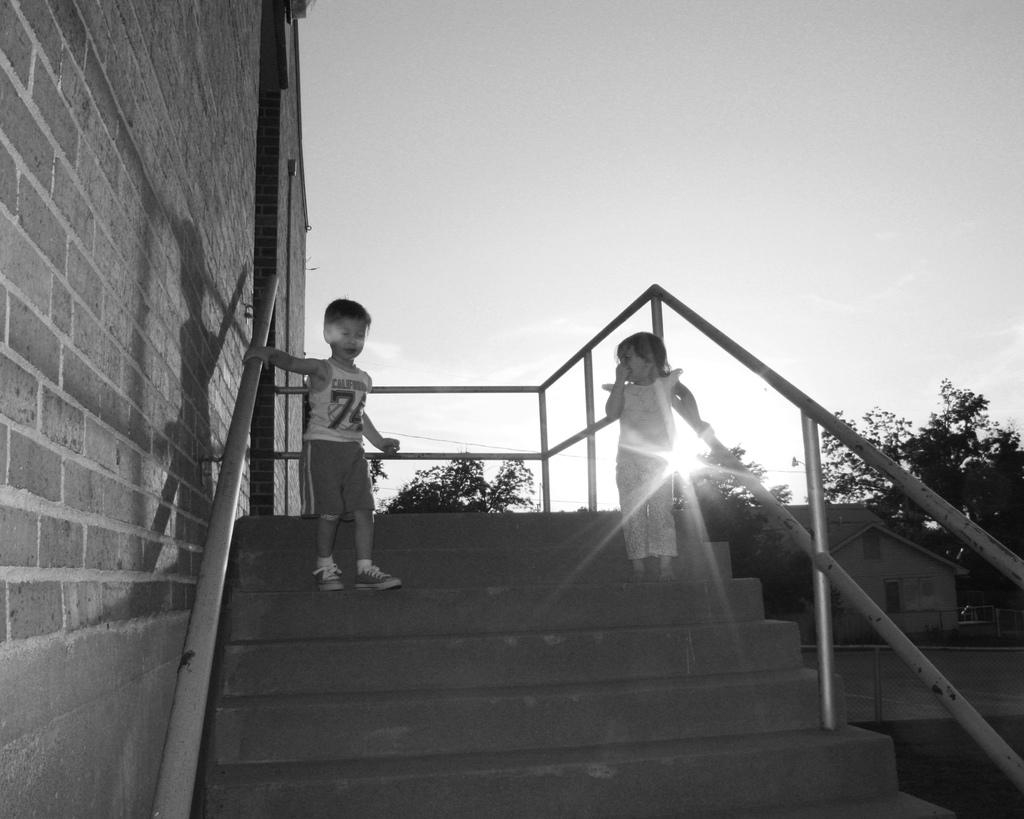How many kids are present in the image? There are two kids in the image. What are the kids doing in the image? The kids are standing on the stairs. What can be seen in the background of the image? There are trees and a building visible in the background. What is the color scheme of the image? The image is in black and white color. What type of cabbage is being played on the guitar in the image? There is no cabbage or guitar present in the image. 